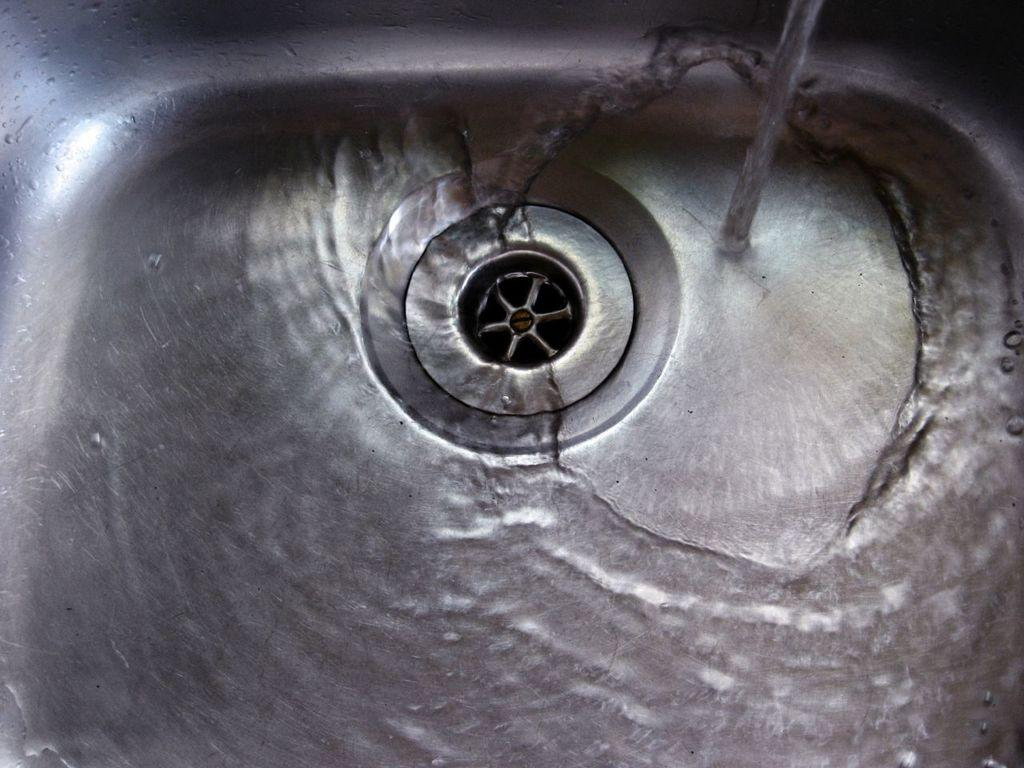What can be seen in the image that is typically found in a home? There is a sink in the image, which is commonly found in homes. What is the current state of the sink in the image? There is water in the sink, and water is flowing at the top of the sink. Where is the basket located in the image? There is no basket present in the image. What type of sound does the whistle make in the image? There is no whistle present in the image. 